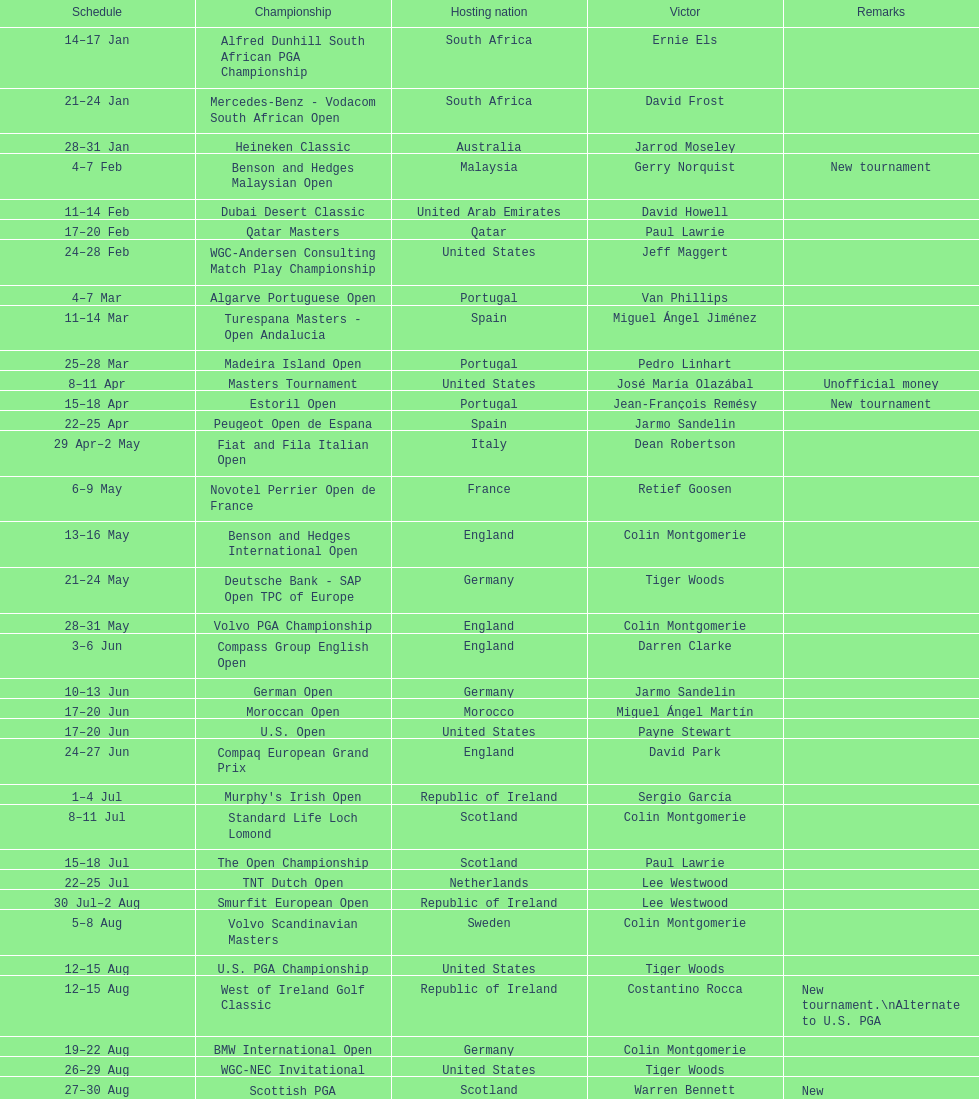Which country was named during the inaugural instance of a novel tournament? Malaysia. 